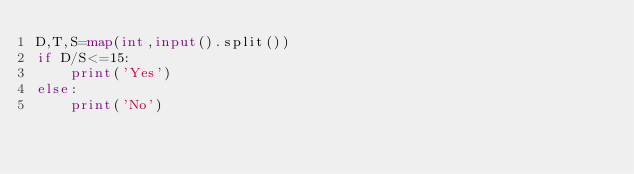Convert code to text. <code><loc_0><loc_0><loc_500><loc_500><_Python_>D,T,S=map(int,input().split())
if D/S<=15:
    print('Yes')
else:
	print('No')</code> 